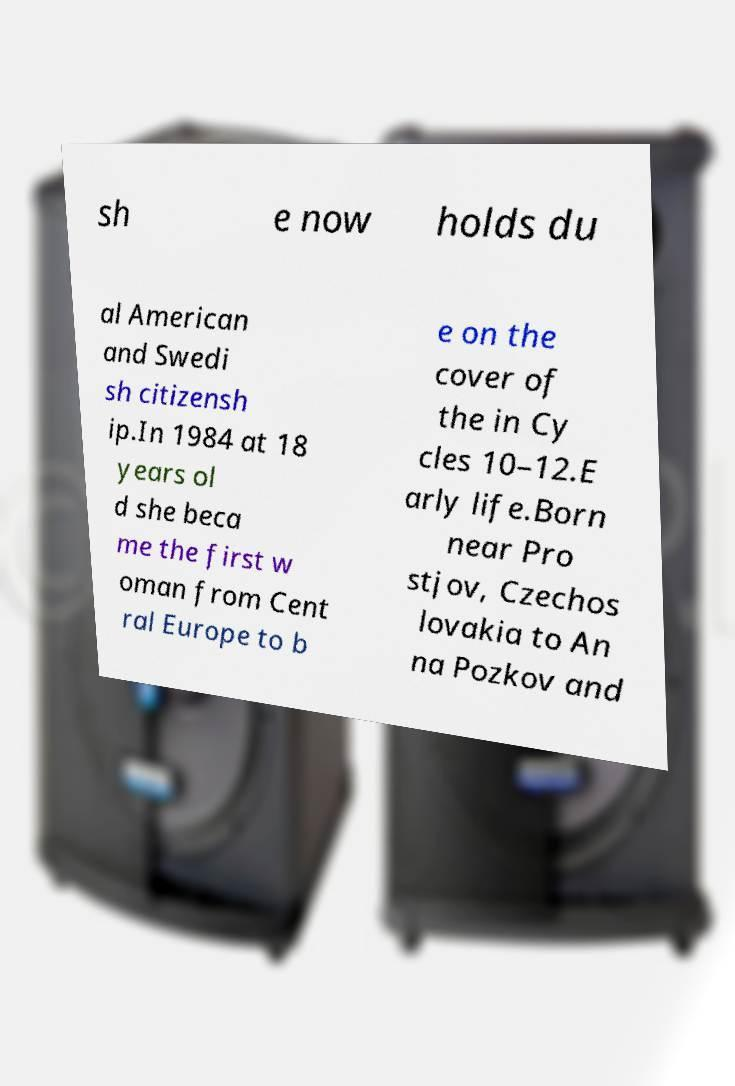Please read and relay the text visible in this image. What does it say? sh e now holds du al American and Swedi sh citizensh ip.In 1984 at 18 years ol d she beca me the first w oman from Cent ral Europe to b e on the cover of the in Cy cles 10–12.E arly life.Born near Pro stjov, Czechos lovakia to An na Pozkov and 